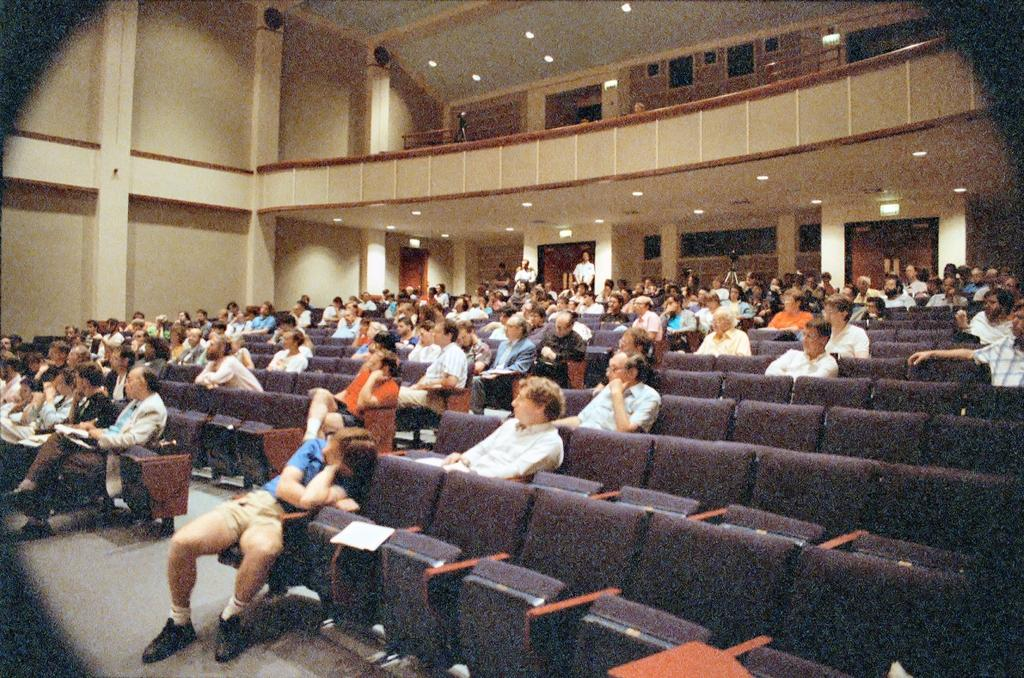What is present in the background of the image? There is a wall in the image. What are the people in the image doing? The people are sitting on chairs in the image. What type of lettuce can be seen growing in the yard in the image? There is no yard or lettuce present in the image; it only features a wall and people sitting on chairs. 